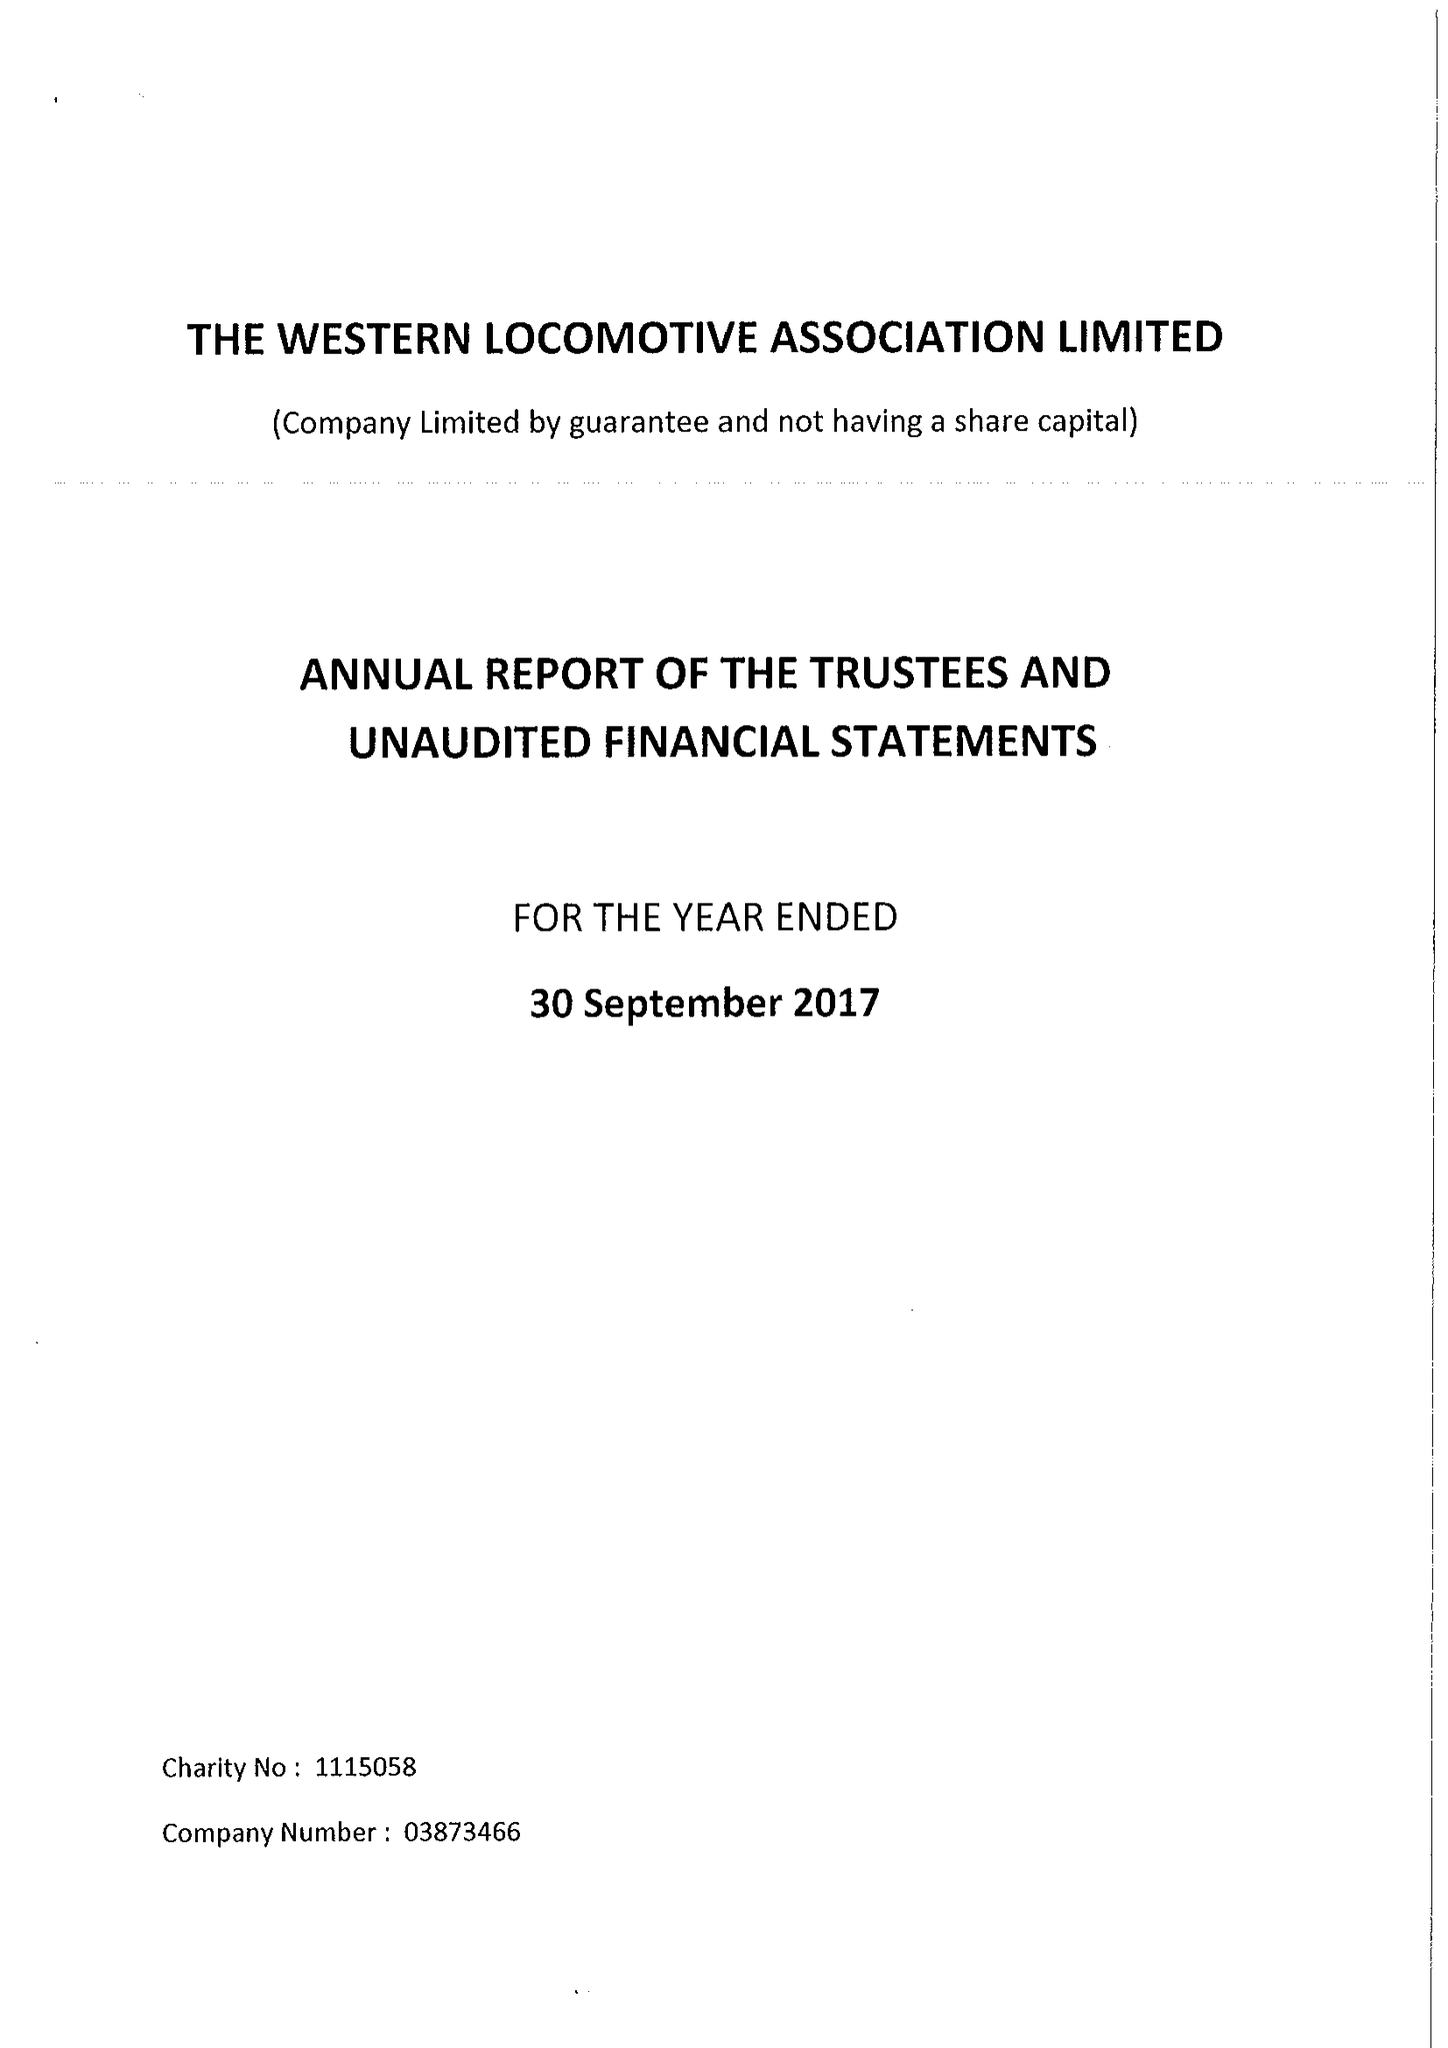What is the value for the address__street_line?
Answer the question using a single word or phrase. 27 COMPTON ROAD 